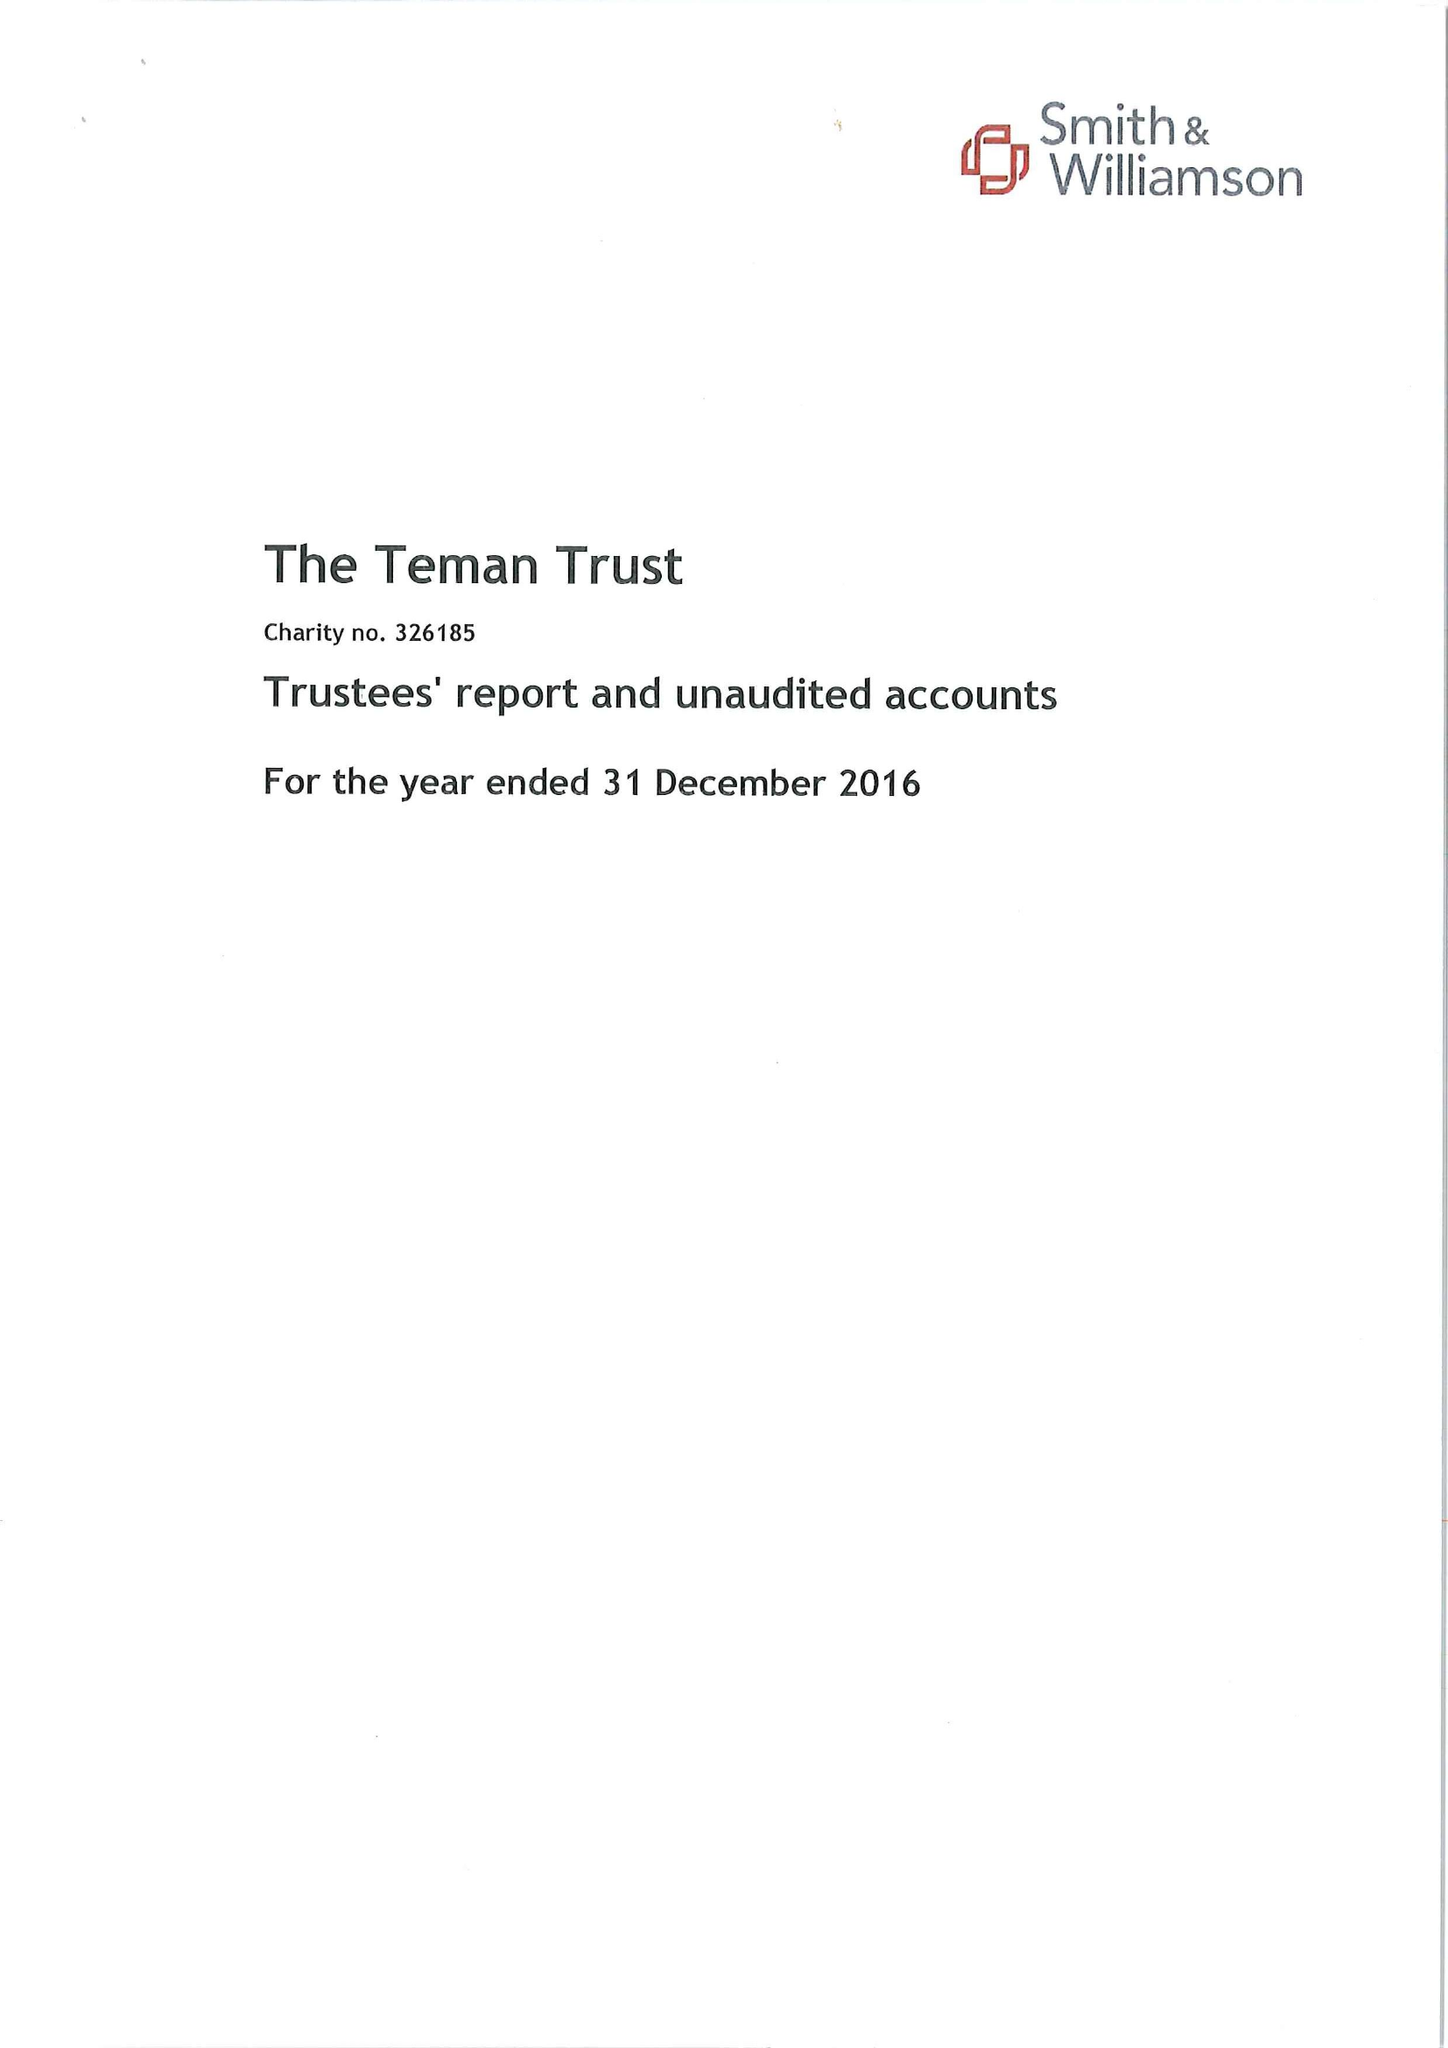What is the value for the income_annually_in_british_pounds?
Answer the question using a single word or phrase. 51893.00 